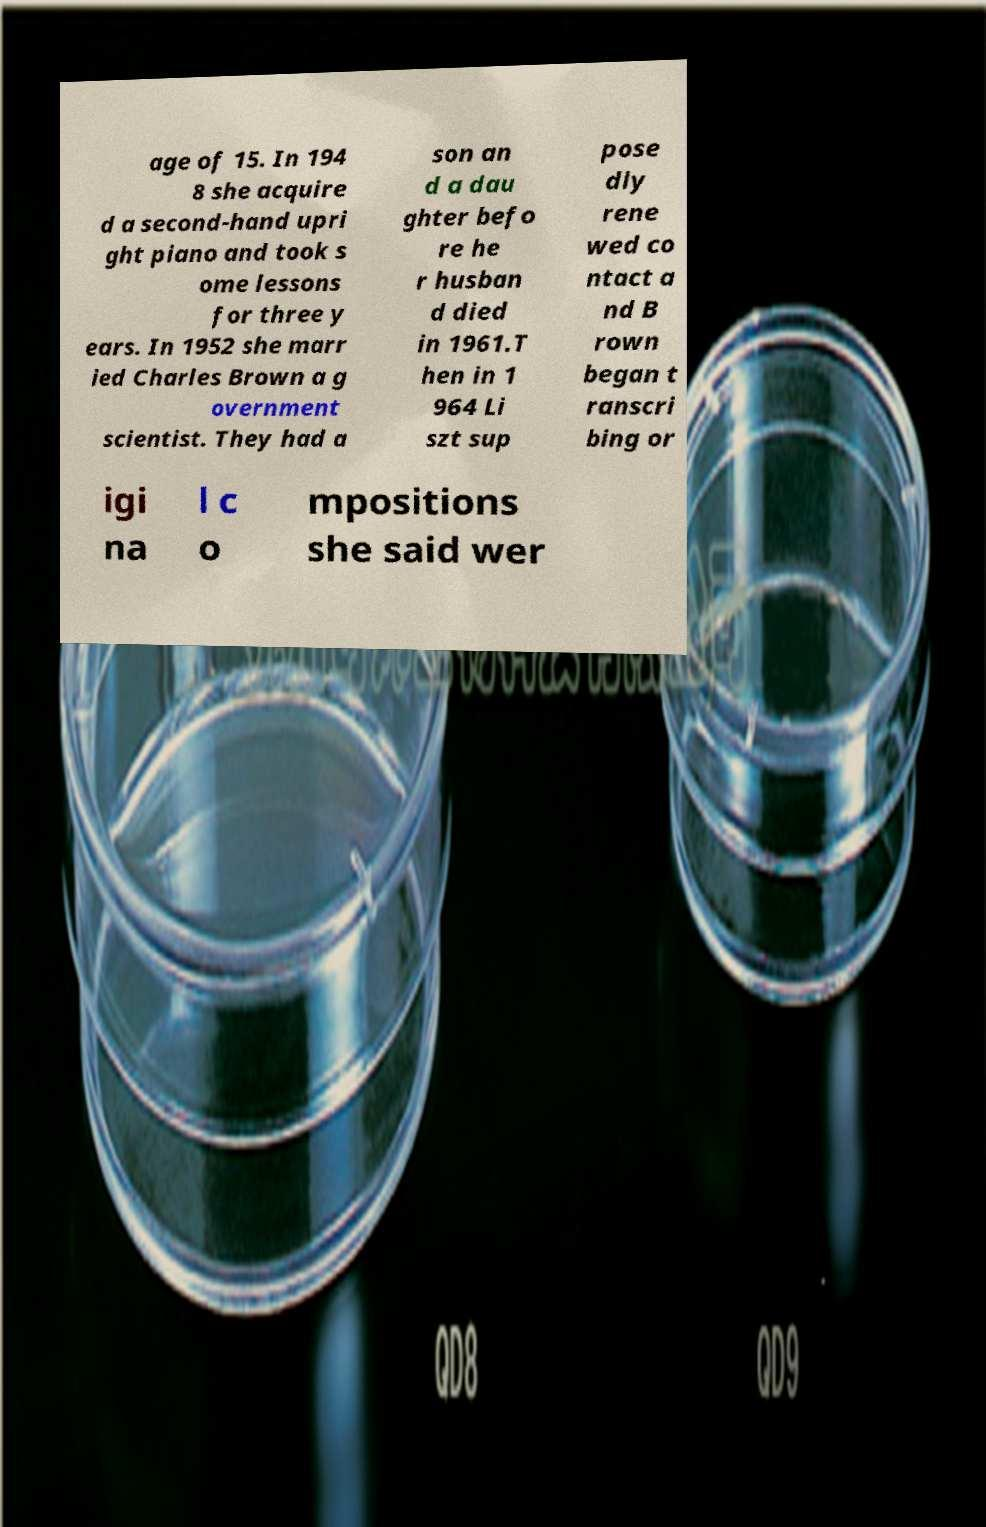Please identify and transcribe the text found in this image. age of 15. In 194 8 she acquire d a second-hand upri ght piano and took s ome lessons for three y ears. In 1952 she marr ied Charles Brown a g overnment scientist. They had a son an d a dau ghter befo re he r husban d died in 1961.T hen in 1 964 Li szt sup pose dly rene wed co ntact a nd B rown began t ranscri bing or igi na l c o mpositions she said wer 